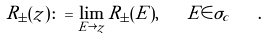Convert formula to latex. <formula><loc_0><loc_0><loc_500><loc_500>R _ { \pm } ( z ) \colon = \lim _ { E \rightarrow z } R _ { \pm } ( E ) , \quad E \in \sigma _ { c } \quad .</formula> 